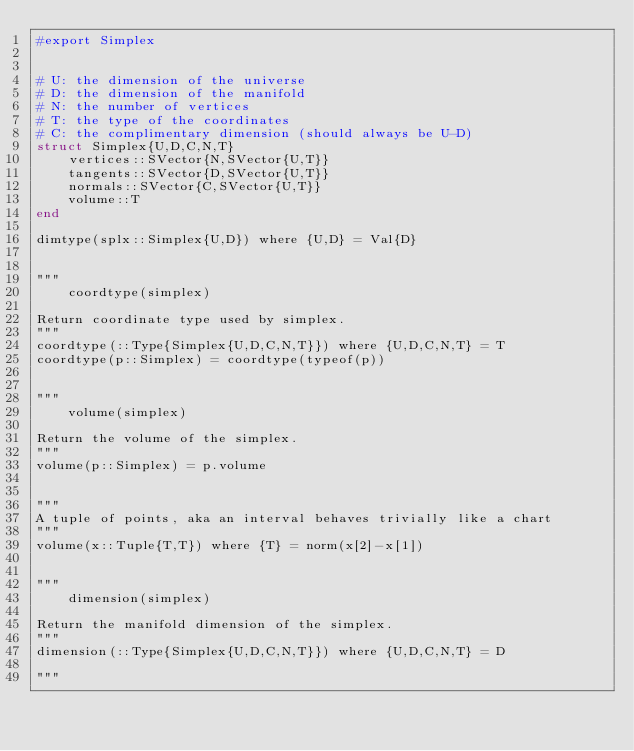Convert code to text. <code><loc_0><loc_0><loc_500><loc_500><_Julia_>#export Simplex


# U: the dimension of the universe
# D: the dimension of the manifold
# N: the number of vertices
# T: the type of the coordinates
# C: the complimentary dimension (should always be U-D)
struct Simplex{U,D,C,N,T}
    vertices::SVector{N,SVector{U,T}}
    tangents::SVector{D,SVector{U,T}}
    normals::SVector{C,SVector{U,T}}
    volume::T
end

dimtype(splx::Simplex{U,D}) where {U,D} = Val{D}


"""
    coordtype(simplex)

Return coordinate type used by simplex.
"""
coordtype(::Type{Simplex{U,D,C,N,T}}) where {U,D,C,N,T} = T
coordtype(p::Simplex) = coordtype(typeof(p))


"""
    volume(simplex)

Return the volume of the simplex.
"""
volume(p::Simplex) = p.volume


"""
A tuple of points, aka an interval behaves trivially like a chart
"""
volume(x::Tuple{T,T}) where {T} = norm(x[2]-x[1])


"""
    dimension(simplex)

Return the manifold dimension of the simplex.
"""
dimension(::Type{Simplex{U,D,C,N,T}}) where {U,D,C,N,T} = D

"""</code> 